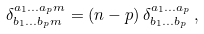Convert formula to latex. <formula><loc_0><loc_0><loc_500><loc_500>\delta ^ { a _ { 1 } \dots a _ { p } m } _ { b _ { 1 } \dots b _ { p } m } = ( n - p ) \, \delta ^ { a _ { 1 } \dots a _ { p } } _ { b _ { 1 } \dots b _ { p } } \, ,</formula> 